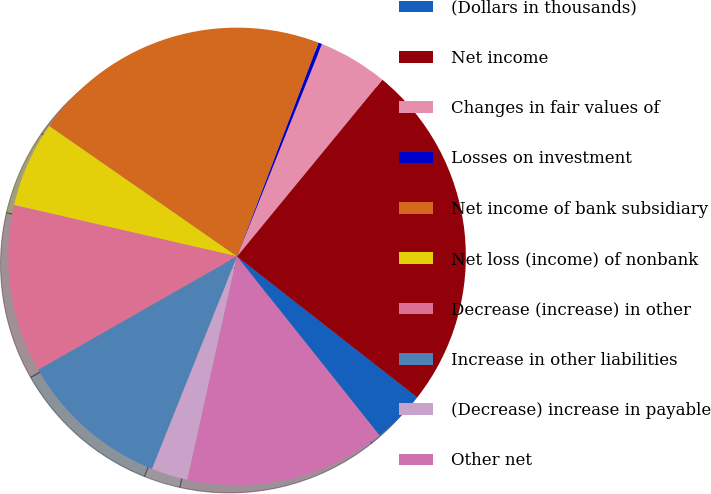Convert chart to OTSL. <chart><loc_0><loc_0><loc_500><loc_500><pie_chart><fcel>(Dollars in thousands)<fcel>Net income<fcel>Changes in fair values of<fcel>Losses on investment<fcel>Net income of bank subsidiary<fcel>Net loss (income) of nonbank<fcel>Decrease (increase) in other<fcel>Increase in other liabilities<fcel>(Decrease) increase in payable<fcel>Other net<nl><fcel>3.74%<fcel>24.62%<fcel>4.9%<fcel>0.26%<fcel>21.14%<fcel>6.06%<fcel>11.86%<fcel>10.7%<fcel>2.58%<fcel>14.18%<nl></chart> 